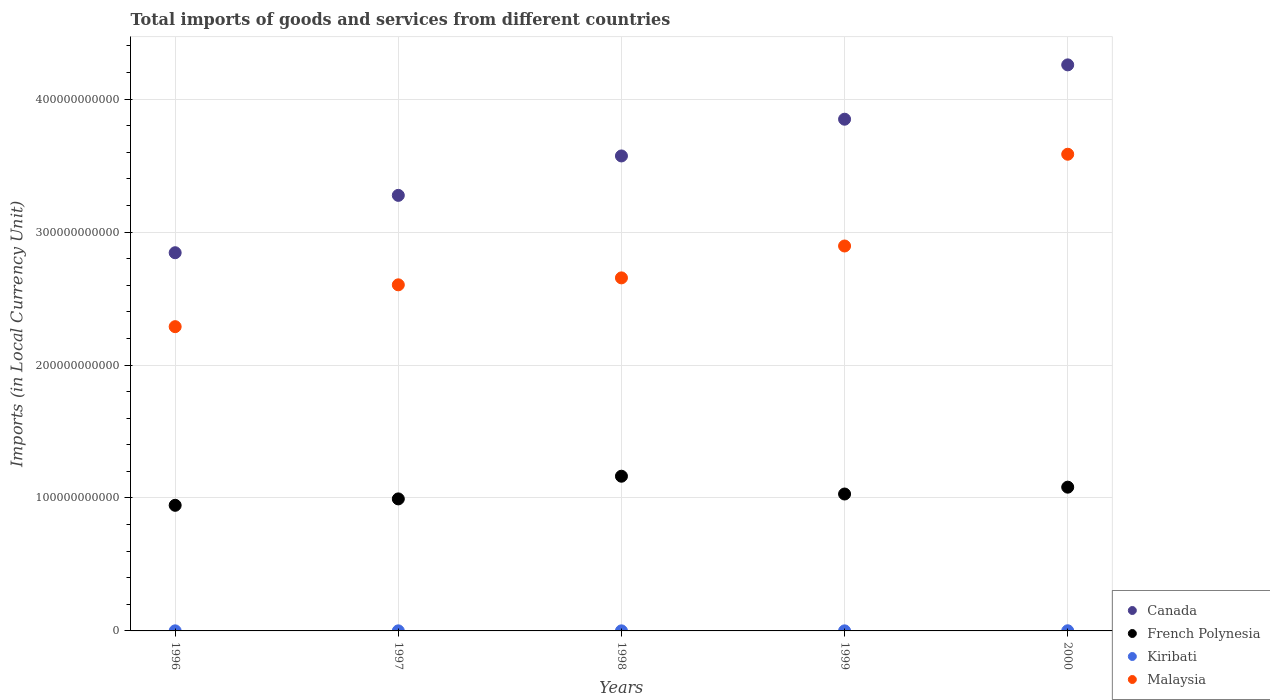Is the number of dotlines equal to the number of legend labels?
Keep it short and to the point. Yes. What is the Amount of goods and services imports in Malaysia in 1999?
Make the answer very short. 2.90e+11. Across all years, what is the maximum Amount of goods and services imports in Canada?
Offer a very short reply. 4.26e+11. Across all years, what is the minimum Amount of goods and services imports in Malaysia?
Ensure brevity in your answer.  2.29e+11. In which year was the Amount of goods and services imports in Canada maximum?
Your response must be concise. 2000. What is the total Amount of goods and services imports in French Polynesia in the graph?
Provide a short and direct response. 5.21e+11. What is the difference between the Amount of goods and services imports in French Polynesia in 1998 and that in 1999?
Offer a very short reply. 1.34e+1. What is the difference between the Amount of goods and services imports in Malaysia in 1997 and the Amount of goods and services imports in French Polynesia in 2000?
Give a very brief answer. 1.52e+11. What is the average Amount of goods and services imports in French Polynesia per year?
Ensure brevity in your answer.  1.04e+11. In the year 1996, what is the difference between the Amount of goods and services imports in French Polynesia and Amount of goods and services imports in Kiribati?
Offer a very short reply. 9.44e+1. In how many years, is the Amount of goods and services imports in Kiribati greater than 400000000000 LCU?
Offer a terse response. 0. What is the ratio of the Amount of goods and services imports in Malaysia in 1997 to that in 1998?
Your answer should be compact. 0.98. What is the difference between the highest and the second highest Amount of goods and services imports in Malaysia?
Offer a terse response. 6.90e+1. What is the difference between the highest and the lowest Amount of goods and services imports in Canada?
Give a very brief answer. 1.41e+11. Is the Amount of goods and services imports in Kiribati strictly greater than the Amount of goods and services imports in French Polynesia over the years?
Provide a short and direct response. No. Is the Amount of goods and services imports in Canada strictly less than the Amount of goods and services imports in French Polynesia over the years?
Your answer should be very brief. No. What is the difference between two consecutive major ticks on the Y-axis?
Provide a succinct answer. 1.00e+11. Are the values on the major ticks of Y-axis written in scientific E-notation?
Your answer should be compact. No. Does the graph contain any zero values?
Your answer should be very brief. No. What is the title of the graph?
Give a very brief answer. Total imports of goods and services from different countries. Does "American Samoa" appear as one of the legend labels in the graph?
Offer a very short reply. No. What is the label or title of the Y-axis?
Provide a short and direct response. Imports (in Local Currency Unit). What is the Imports (in Local Currency Unit) of Canada in 1996?
Offer a very short reply. 2.84e+11. What is the Imports (in Local Currency Unit) of French Polynesia in 1996?
Keep it short and to the point. 9.45e+1. What is the Imports (in Local Currency Unit) of Kiribati in 1996?
Provide a succinct answer. 5.91e+07. What is the Imports (in Local Currency Unit) in Malaysia in 1996?
Offer a terse response. 2.29e+11. What is the Imports (in Local Currency Unit) in Canada in 1997?
Keep it short and to the point. 3.28e+11. What is the Imports (in Local Currency Unit) of French Polynesia in 1997?
Provide a short and direct response. 9.93e+1. What is the Imports (in Local Currency Unit) in Kiribati in 1997?
Your answer should be compact. 5.78e+07. What is the Imports (in Local Currency Unit) of Malaysia in 1997?
Make the answer very short. 2.60e+11. What is the Imports (in Local Currency Unit) of Canada in 1998?
Give a very brief answer. 3.57e+11. What is the Imports (in Local Currency Unit) of French Polynesia in 1998?
Provide a succinct answer. 1.16e+11. What is the Imports (in Local Currency Unit) in Kiribati in 1998?
Provide a succinct answer. 5.53e+07. What is the Imports (in Local Currency Unit) in Malaysia in 1998?
Your response must be concise. 2.66e+11. What is the Imports (in Local Currency Unit) of Canada in 1999?
Your answer should be very brief. 3.85e+11. What is the Imports (in Local Currency Unit) in French Polynesia in 1999?
Keep it short and to the point. 1.03e+11. What is the Imports (in Local Currency Unit) in Kiribati in 1999?
Keep it short and to the point. 5.76e+07. What is the Imports (in Local Currency Unit) in Malaysia in 1999?
Your response must be concise. 2.90e+11. What is the Imports (in Local Currency Unit) of Canada in 2000?
Keep it short and to the point. 4.26e+11. What is the Imports (in Local Currency Unit) of French Polynesia in 2000?
Make the answer very short. 1.08e+11. What is the Imports (in Local Currency Unit) of Kiribati in 2000?
Offer a very short reply. 1.08e+08. What is the Imports (in Local Currency Unit) of Malaysia in 2000?
Keep it short and to the point. 3.59e+11. Across all years, what is the maximum Imports (in Local Currency Unit) of Canada?
Make the answer very short. 4.26e+11. Across all years, what is the maximum Imports (in Local Currency Unit) of French Polynesia?
Provide a short and direct response. 1.16e+11. Across all years, what is the maximum Imports (in Local Currency Unit) in Kiribati?
Your response must be concise. 1.08e+08. Across all years, what is the maximum Imports (in Local Currency Unit) in Malaysia?
Provide a short and direct response. 3.59e+11. Across all years, what is the minimum Imports (in Local Currency Unit) of Canada?
Keep it short and to the point. 2.84e+11. Across all years, what is the minimum Imports (in Local Currency Unit) of French Polynesia?
Offer a terse response. 9.45e+1. Across all years, what is the minimum Imports (in Local Currency Unit) of Kiribati?
Offer a terse response. 5.53e+07. Across all years, what is the minimum Imports (in Local Currency Unit) in Malaysia?
Offer a very short reply. 2.29e+11. What is the total Imports (in Local Currency Unit) in Canada in the graph?
Offer a terse response. 1.78e+12. What is the total Imports (in Local Currency Unit) of French Polynesia in the graph?
Offer a very short reply. 5.21e+11. What is the total Imports (in Local Currency Unit) in Kiribati in the graph?
Offer a terse response. 3.38e+08. What is the total Imports (in Local Currency Unit) of Malaysia in the graph?
Keep it short and to the point. 1.40e+12. What is the difference between the Imports (in Local Currency Unit) in Canada in 1996 and that in 1997?
Provide a short and direct response. -4.31e+1. What is the difference between the Imports (in Local Currency Unit) of French Polynesia in 1996 and that in 1997?
Offer a terse response. -4.82e+09. What is the difference between the Imports (in Local Currency Unit) in Kiribati in 1996 and that in 1997?
Make the answer very short. 1.30e+06. What is the difference between the Imports (in Local Currency Unit) of Malaysia in 1996 and that in 1997?
Your response must be concise. -3.15e+1. What is the difference between the Imports (in Local Currency Unit) in Canada in 1996 and that in 1998?
Keep it short and to the point. -7.28e+1. What is the difference between the Imports (in Local Currency Unit) of French Polynesia in 1996 and that in 1998?
Offer a very short reply. -2.19e+1. What is the difference between the Imports (in Local Currency Unit) of Kiribati in 1996 and that in 1998?
Your answer should be compact. 3.78e+06. What is the difference between the Imports (in Local Currency Unit) of Malaysia in 1996 and that in 1998?
Ensure brevity in your answer.  -3.67e+1. What is the difference between the Imports (in Local Currency Unit) of Canada in 1996 and that in 1999?
Your answer should be compact. -1.00e+11. What is the difference between the Imports (in Local Currency Unit) in French Polynesia in 1996 and that in 1999?
Ensure brevity in your answer.  -8.49e+09. What is the difference between the Imports (in Local Currency Unit) of Kiribati in 1996 and that in 1999?
Your answer should be compact. 1.50e+06. What is the difference between the Imports (in Local Currency Unit) in Malaysia in 1996 and that in 1999?
Offer a very short reply. -6.07e+1. What is the difference between the Imports (in Local Currency Unit) in Canada in 1996 and that in 2000?
Your answer should be very brief. -1.41e+11. What is the difference between the Imports (in Local Currency Unit) in French Polynesia in 1996 and that in 2000?
Offer a very short reply. -1.36e+1. What is the difference between the Imports (in Local Currency Unit) of Kiribati in 1996 and that in 2000?
Your answer should be very brief. -4.87e+07. What is the difference between the Imports (in Local Currency Unit) of Malaysia in 1996 and that in 2000?
Offer a terse response. -1.30e+11. What is the difference between the Imports (in Local Currency Unit) in Canada in 1997 and that in 1998?
Make the answer very short. -2.96e+1. What is the difference between the Imports (in Local Currency Unit) in French Polynesia in 1997 and that in 1998?
Your response must be concise. -1.71e+1. What is the difference between the Imports (in Local Currency Unit) in Kiribati in 1997 and that in 1998?
Your answer should be compact. 2.48e+06. What is the difference between the Imports (in Local Currency Unit) of Malaysia in 1997 and that in 1998?
Your answer should be very brief. -5.23e+09. What is the difference between the Imports (in Local Currency Unit) in Canada in 1997 and that in 1999?
Make the answer very short. -5.73e+1. What is the difference between the Imports (in Local Currency Unit) in French Polynesia in 1997 and that in 1999?
Provide a short and direct response. -3.67e+09. What is the difference between the Imports (in Local Currency Unit) in Malaysia in 1997 and that in 1999?
Your response must be concise. -2.92e+1. What is the difference between the Imports (in Local Currency Unit) of Canada in 1997 and that in 2000?
Ensure brevity in your answer.  -9.82e+1. What is the difference between the Imports (in Local Currency Unit) of French Polynesia in 1997 and that in 2000?
Your answer should be compact. -8.82e+09. What is the difference between the Imports (in Local Currency Unit) of Kiribati in 1997 and that in 2000?
Offer a terse response. -5.00e+07. What is the difference between the Imports (in Local Currency Unit) of Malaysia in 1997 and that in 2000?
Offer a very short reply. -9.82e+1. What is the difference between the Imports (in Local Currency Unit) of Canada in 1998 and that in 1999?
Offer a very short reply. -2.76e+1. What is the difference between the Imports (in Local Currency Unit) of French Polynesia in 1998 and that in 1999?
Your answer should be very brief. 1.34e+1. What is the difference between the Imports (in Local Currency Unit) in Kiribati in 1998 and that in 1999?
Provide a short and direct response. -2.28e+06. What is the difference between the Imports (in Local Currency Unit) of Malaysia in 1998 and that in 1999?
Provide a short and direct response. -2.40e+1. What is the difference between the Imports (in Local Currency Unit) in Canada in 1998 and that in 2000?
Your answer should be very brief. -6.85e+1. What is the difference between the Imports (in Local Currency Unit) in French Polynesia in 1998 and that in 2000?
Provide a succinct answer. 8.23e+09. What is the difference between the Imports (in Local Currency Unit) in Kiribati in 1998 and that in 2000?
Provide a succinct answer. -5.24e+07. What is the difference between the Imports (in Local Currency Unit) in Malaysia in 1998 and that in 2000?
Your answer should be compact. -9.30e+1. What is the difference between the Imports (in Local Currency Unit) in Canada in 1999 and that in 2000?
Your answer should be very brief. -4.09e+1. What is the difference between the Imports (in Local Currency Unit) in French Polynesia in 1999 and that in 2000?
Provide a succinct answer. -5.15e+09. What is the difference between the Imports (in Local Currency Unit) of Kiribati in 1999 and that in 2000?
Offer a terse response. -5.02e+07. What is the difference between the Imports (in Local Currency Unit) of Malaysia in 1999 and that in 2000?
Give a very brief answer. -6.90e+1. What is the difference between the Imports (in Local Currency Unit) in Canada in 1996 and the Imports (in Local Currency Unit) in French Polynesia in 1997?
Ensure brevity in your answer.  1.85e+11. What is the difference between the Imports (in Local Currency Unit) in Canada in 1996 and the Imports (in Local Currency Unit) in Kiribati in 1997?
Offer a very short reply. 2.84e+11. What is the difference between the Imports (in Local Currency Unit) of Canada in 1996 and the Imports (in Local Currency Unit) of Malaysia in 1997?
Offer a terse response. 2.41e+1. What is the difference between the Imports (in Local Currency Unit) in French Polynesia in 1996 and the Imports (in Local Currency Unit) in Kiribati in 1997?
Your response must be concise. 9.44e+1. What is the difference between the Imports (in Local Currency Unit) in French Polynesia in 1996 and the Imports (in Local Currency Unit) in Malaysia in 1997?
Keep it short and to the point. -1.66e+11. What is the difference between the Imports (in Local Currency Unit) in Kiribati in 1996 and the Imports (in Local Currency Unit) in Malaysia in 1997?
Give a very brief answer. -2.60e+11. What is the difference between the Imports (in Local Currency Unit) of Canada in 1996 and the Imports (in Local Currency Unit) of French Polynesia in 1998?
Make the answer very short. 1.68e+11. What is the difference between the Imports (in Local Currency Unit) in Canada in 1996 and the Imports (in Local Currency Unit) in Kiribati in 1998?
Ensure brevity in your answer.  2.84e+11. What is the difference between the Imports (in Local Currency Unit) in Canada in 1996 and the Imports (in Local Currency Unit) in Malaysia in 1998?
Your answer should be compact. 1.89e+1. What is the difference between the Imports (in Local Currency Unit) of French Polynesia in 1996 and the Imports (in Local Currency Unit) of Kiribati in 1998?
Your answer should be compact. 9.44e+1. What is the difference between the Imports (in Local Currency Unit) of French Polynesia in 1996 and the Imports (in Local Currency Unit) of Malaysia in 1998?
Your answer should be very brief. -1.71e+11. What is the difference between the Imports (in Local Currency Unit) in Kiribati in 1996 and the Imports (in Local Currency Unit) in Malaysia in 1998?
Give a very brief answer. -2.65e+11. What is the difference between the Imports (in Local Currency Unit) in Canada in 1996 and the Imports (in Local Currency Unit) in French Polynesia in 1999?
Your response must be concise. 1.81e+11. What is the difference between the Imports (in Local Currency Unit) of Canada in 1996 and the Imports (in Local Currency Unit) of Kiribati in 1999?
Provide a succinct answer. 2.84e+11. What is the difference between the Imports (in Local Currency Unit) in Canada in 1996 and the Imports (in Local Currency Unit) in Malaysia in 1999?
Provide a short and direct response. -5.06e+09. What is the difference between the Imports (in Local Currency Unit) of French Polynesia in 1996 and the Imports (in Local Currency Unit) of Kiribati in 1999?
Give a very brief answer. 9.44e+1. What is the difference between the Imports (in Local Currency Unit) of French Polynesia in 1996 and the Imports (in Local Currency Unit) of Malaysia in 1999?
Provide a short and direct response. -1.95e+11. What is the difference between the Imports (in Local Currency Unit) of Kiribati in 1996 and the Imports (in Local Currency Unit) of Malaysia in 1999?
Make the answer very short. -2.89e+11. What is the difference between the Imports (in Local Currency Unit) of Canada in 1996 and the Imports (in Local Currency Unit) of French Polynesia in 2000?
Your response must be concise. 1.76e+11. What is the difference between the Imports (in Local Currency Unit) of Canada in 1996 and the Imports (in Local Currency Unit) of Kiribati in 2000?
Provide a short and direct response. 2.84e+11. What is the difference between the Imports (in Local Currency Unit) of Canada in 1996 and the Imports (in Local Currency Unit) of Malaysia in 2000?
Provide a succinct answer. -7.41e+1. What is the difference between the Imports (in Local Currency Unit) in French Polynesia in 1996 and the Imports (in Local Currency Unit) in Kiribati in 2000?
Your answer should be very brief. 9.44e+1. What is the difference between the Imports (in Local Currency Unit) of French Polynesia in 1996 and the Imports (in Local Currency Unit) of Malaysia in 2000?
Your answer should be very brief. -2.64e+11. What is the difference between the Imports (in Local Currency Unit) in Kiribati in 1996 and the Imports (in Local Currency Unit) in Malaysia in 2000?
Make the answer very short. -3.58e+11. What is the difference between the Imports (in Local Currency Unit) of Canada in 1997 and the Imports (in Local Currency Unit) of French Polynesia in 1998?
Ensure brevity in your answer.  2.11e+11. What is the difference between the Imports (in Local Currency Unit) of Canada in 1997 and the Imports (in Local Currency Unit) of Kiribati in 1998?
Your answer should be compact. 3.28e+11. What is the difference between the Imports (in Local Currency Unit) in Canada in 1997 and the Imports (in Local Currency Unit) in Malaysia in 1998?
Your response must be concise. 6.21e+1. What is the difference between the Imports (in Local Currency Unit) in French Polynesia in 1997 and the Imports (in Local Currency Unit) in Kiribati in 1998?
Offer a very short reply. 9.92e+1. What is the difference between the Imports (in Local Currency Unit) of French Polynesia in 1997 and the Imports (in Local Currency Unit) of Malaysia in 1998?
Your answer should be very brief. -1.66e+11. What is the difference between the Imports (in Local Currency Unit) of Kiribati in 1997 and the Imports (in Local Currency Unit) of Malaysia in 1998?
Offer a very short reply. -2.65e+11. What is the difference between the Imports (in Local Currency Unit) of Canada in 1997 and the Imports (in Local Currency Unit) of French Polynesia in 1999?
Offer a terse response. 2.25e+11. What is the difference between the Imports (in Local Currency Unit) in Canada in 1997 and the Imports (in Local Currency Unit) in Kiribati in 1999?
Make the answer very short. 3.28e+11. What is the difference between the Imports (in Local Currency Unit) of Canada in 1997 and the Imports (in Local Currency Unit) of Malaysia in 1999?
Your response must be concise. 3.81e+1. What is the difference between the Imports (in Local Currency Unit) of French Polynesia in 1997 and the Imports (in Local Currency Unit) of Kiribati in 1999?
Your response must be concise. 9.92e+1. What is the difference between the Imports (in Local Currency Unit) of French Polynesia in 1997 and the Imports (in Local Currency Unit) of Malaysia in 1999?
Offer a very short reply. -1.90e+11. What is the difference between the Imports (in Local Currency Unit) in Kiribati in 1997 and the Imports (in Local Currency Unit) in Malaysia in 1999?
Offer a very short reply. -2.89e+11. What is the difference between the Imports (in Local Currency Unit) in Canada in 1997 and the Imports (in Local Currency Unit) in French Polynesia in 2000?
Ensure brevity in your answer.  2.19e+11. What is the difference between the Imports (in Local Currency Unit) of Canada in 1997 and the Imports (in Local Currency Unit) of Kiribati in 2000?
Your answer should be very brief. 3.27e+11. What is the difference between the Imports (in Local Currency Unit) of Canada in 1997 and the Imports (in Local Currency Unit) of Malaysia in 2000?
Keep it short and to the point. -3.09e+1. What is the difference between the Imports (in Local Currency Unit) in French Polynesia in 1997 and the Imports (in Local Currency Unit) in Kiribati in 2000?
Offer a very short reply. 9.92e+1. What is the difference between the Imports (in Local Currency Unit) in French Polynesia in 1997 and the Imports (in Local Currency Unit) in Malaysia in 2000?
Your response must be concise. -2.59e+11. What is the difference between the Imports (in Local Currency Unit) of Kiribati in 1997 and the Imports (in Local Currency Unit) of Malaysia in 2000?
Keep it short and to the point. -3.58e+11. What is the difference between the Imports (in Local Currency Unit) of Canada in 1998 and the Imports (in Local Currency Unit) of French Polynesia in 1999?
Your response must be concise. 2.54e+11. What is the difference between the Imports (in Local Currency Unit) of Canada in 1998 and the Imports (in Local Currency Unit) of Kiribati in 1999?
Provide a short and direct response. 3.57e+11. What is the difference between the Imports (in Local Currency Unit) of Canada in 1998 and the Imports (in Local Currency Unit) of Malaysia in 1999?
Provide a succinct answer. 6.77e+1. What is the difference between the Imports (in Local Currency Unit) in French Polynesia in 1998 and the Imports (in Local Currency Unit) in Kiribati in 1999?
Keep it short and to the point. 1.16e+11. What is the difference between the Imports (in Local Currency Unit) of French Polynesia in 1998 and the Imports (in Local Currency Unit) of Malaysia in 1999?
Provide a short and direct response. -1.73e+11. What is the difference between the Imports (in Local Currency Unit) of Kiribati in 1998 and the Imports (in Local Currency Unit) of Malaysia in 1999?
Offer a very short reply. -2.89e+11. What is the difference between the Imports (in Local Currency Unit) of Canada in 1998 and the Imports (in Local Currency Unit) of French Polynesia in 2000?
Offer a terse response. 2.49e+11. What is the difference between the Imports (in Local Currency Unit) of Canada in 1998 and the Imports (in Local Currency Unit) of Kiribati in 2000?
Ensure brevity in your answer.  3.57e+11. What is the difference between the Imports (in Local Currency Unit) of Canada in 1998 and the Imports (in Local Currency Unit) of Malaysia in 2000?
Offer a terse response. -1.29e+09. What is the difference between the Imports (in Local Currency Unit) of French Polynesia in 1998 and the Imports (in Local Currency Unit) of Kiribati in 2000?
Offer a terse response. 1.16e+11. What is the difference between the Imports (in Local Currency Unit) in French Polynesia in 1998 and the Imports (in Local Currency Unit) in Malaysia in 2000?
Provide a short and direct response. -2.42e+11. What is the difference between the Imports (in Local Currency Unit) of Kiribati in 1998 and the Imports (in Local Currency Unit) of Malaysia in 2000?
Make the answer very short. -3.58e+11. What is the difference between the Imports (in Local Currency Unit) in Canada in 1999 and the Imports (in Local Currency Unit) in French Polynesia in 2000?
Offer a very short reply. 2.77e+11. What is the difference between the Imports (in Local Currency Unit) in Canada in 1999 and the Imports (in Local Currency Unit) in Kiribati in 2000?
Your answer should be compact. 3.85e+11. What is the difference between the Imports (in Local Currency Unit) in Canada in 1999 and the Imports (in Local Currency Unit) in Malaysia in 2000?
Make the answer very short. 2.63e+1. What is the difference between the Imports (in Local Currency Unit) of French Polynesia in 1999 and the Imports (in Local Currency Unit) of Kiribati in 2000?
Keep it short and to the point. 1.03e+11. What is the difference between the Imports (in Local Currency Unit) in French Polynesia in 1999 and the Imports (in Local Currency Unit) in Malaysia in 2000?
Keep it short and to the point. -2.56e+11. What is the difference between the Imports (in Local Currency Unit) of Kiribati in 1999 and the Imports (in Local Currency Unit) of Malaysia in 2000?
Your response must be concise. -3.58e+11. What is the average Imports (in Local Currency Unit) in Canada per year?
Your answer should be compact. 3.56e+11. What is the average Imports (in Local Currency Unit) in French Polynesia per year?
Your answer should be compact. 1.04e+11. What is the average Imports (in Local Currency Unit) of Kiribati per year?
Provide a succinct answer. 6.75e+07. What is the average Imports (in Local Currency Unit) of Malaysia per year?
Keep it short and to the point. 2.81e+11. In the year 1996, what is the difference between the Imports (in Local Currency Unit) in Canada and Imports (in Local Currency Unit) in French Polynesia?
Offer a terse response. 1.90e+11. In the year 1996, what is the difference between the Imports (in Local Currency Unit) in Canada and Imports (in Local Currency Unit) in Kiribati?
Offer a terse response. 2.84e+11. In the year 1996, what is the difference between the Imports (in Local Currency Unit) of Canada and Imports (in Local Currency Unit) of Malaysia?
Provide a succinct answer. 5.56e+1. In the year 1996, what is the difference between the Imports (in Local Currency Unit) in French Polynesia and Imports (in Local Currency Unit) in Kiribati?
Give a very brief answer. 9.44e+1. In the year 1996, what is the difference between the Imports (in Local Currency Unit) in French Polynesia and Imports (in Local Currency Unit) in Malaysia?
Your answer should be compact. -1.34e+11. In the year 1996, what is the difference between the Imports (in Local Currency Unit) in Kiribati and Imports (in Local Currency Unit) in Malaysia?
Provide a succinct answer. -2.29e+11. In the year 1997, what is the difference between the Imports (in Local Currency Unit) in Canada and Imports (in Local Currency Unit) in French Polynesia?
Make the answer very short. 2.28e+11. In the year 1997, what is the difference between the Imports (in Local Currency Unit) of Canada and Imports (in Local Currency Unit) of Kiribati?
Make the answer very short. 3.28e+11. In the year 1997, what is the difference between the Imports (in Local Currency Unit) of Canada and Imports (in Local Currency Unit) of Malaysia?
Your response must be concise. 6.73e+1. In the year 1997, what is the difference between the Imports (in Local Currency Unit) of French Polynesia and Imports (in Local Currency Unit) of Kiribati?
Provide a short and direct response. 9.92e+1. In the year 1997, what is the difference between the Imports (in Local Currency Unit) in French Polynesia and Imports (in Local Currency Unit) in Malaysia?
Your response must be concise. -1.61e+11. In the year 1997, what is the difference between the Imports (in Local Currency Unit) of Kiribati and Imports (in Local Currency Unit) of Malaysia?
Give a very brief answer. -2.60e+11. In the year 1998, what is the difference between the Imports (in Local Currency Unit) of Canada and Imports (in Local Currency Unit) of French Polynesia?
Your response must be concise. 2.41e+11. In the year 1998, what is the difference between the Imports (in Local Currency Unit) of Canada and Imports (in Local Currency Unit) of Kiribati?
Offer a very short reply. 3.57e+11. In the year 1998, what is the difference between the Imports (in Local Currency Unit) of Canada and Imports (in Local Currency Unit) of Malaysia?
Your answer should be very brief. 9.17e+1. In the year 1998, what is the difference between the Imports (in Local Currency Unit) in French Polynesia and Imports (in Local Currency Unit) in Kiribati?
Your response must be concise. 1.16e+11. In the year 1998, what is the difference between the Imports (in Local Currency Unit) in French Polynesia and Imports (in Local Currency Unit) in Malaysia?
Your response must be concise. -1.49e+11. In the year 1998, what is the difference between the Imports (in Local Currency Unit) in Kiribati and Imports (in Local Currency Unit) in Malaysia?
Make the answer very short. -2.65e+11. In the year 1999, what is the difference between the Imports (in Local Currency Unit) of Canada and Imports (in Local Currency Unit) of French Polynesia?
Offer a very short reply. 2.82e+11. In the year 1999, what is the difference between the Imports (in Local Currency Unit) in Canada and Imports (in Local Currency Unit) in Kiribati?
Your response must be concise. 3.85e+11. In the year 1999, what is the difference between the Imports (in Local Currency Unit) of Canada and Imports (in Local Currency Unit) of Malaysia?
Keep it short and to the point. 9.54e+1. In the year 1999, what is the difference between the Imports (in Local Currency Unit) in French Polynesia and Imports (in Local Currency Unit) in Kiribati?
Your answer should be very brief. 1.03e+11. In the year 1999, what is the difference between the Imports (in Local Currency Unit) of French Polynesia and Imports (in Local Currency Unit) of Malaysia?
Provide a short and direct response. -1.87e+11. In the year 1999, what is the difference between the Imports (in Local Currency Unit) of Kiribati and Imports (in Local Currency Unit) of Malaysia?
Your response must be concise. -2.89e+11. In the year 2000, what is the difference between the Imports (in Local Currency Unit) of Canada and Imports (in Local Currency Unit) of French Polynesia?
Ensure brevity in your answer.  3.18e+11. In the year 2000, what is the difference between the Imports (in Local Currency Unit) of Canada and Imports (in Local Currency Unit) of Kiribati?
Offer a very short reply. 4.26e+11. In the year 2000, what is the difference between the Imports (in Local Currency Unit) in Canada and Imports (in Local Currency Unit) in Malaysia?
Offer a terse response. 6.72e+1. In the year 2000, what is the difference between the Imports (in Local Currency Unit) of French Polynesia and Imports (in Local Currency Unit) of Kiribati?
Provide a short and direct response. 1.08e+11. In the year 2000, what is the difference between the Imports (in Local Currency Unit) in French Polynesia and Imports (in Local Currency Unit) in Malaysia?
Keep it short and to the point. -2.50e+11. In the year 2000, what is the difference between the Imports (in Local Currency Unit) in Kiribati and Imports (in Local Currency Unit) in Malaysia?
Provide a succinct answer. -3.58e+11. What is the ratio of the Imports (in Local Currency Unit) in Canada in 1996 to that in 1997?
Your answer should be very brief. 0.87. What is the ratio of the Imports (in Local Currency Unit) in French Polynesia in 1996 to that in 1997?
Your response must be concise. 0.95. What is the ratio of the Imports (in Local Currency Unit) in Kiribati in 1996 to that in 1997?
Your answer should be very brief. 1.02. What is the ratio of the Imports (in Local Currency Unit) in Malaysia in 1996 to that in 1997?
Your answer should be very brief. 0.88. What is the ratio of the Imports (in Local Currency Unit) in Canada in 1996 to that in 1998?
Keep it short and to the point. 0.8. What is the ratio of the Imports (in Local Currency Unit) in French Polynesia in 1996 to that in 1998?
Make the answer very short. 0.81. What is the ratio of the Imports (in Local Currency Unit) of Kiribati in 1996 to that in 1998?
Make the answer very short. 1.07. What is the ratio of the Imports (in Local Currency Unit) in Malaysia in 1996 to that in 1998?
Give a very brief answer. 0.86. What is the ratio of the Imports (in Local Currency Unit) of Canada in 1996 to that in 1999?
Offer a terse response. 0.74. What is the ratio of the Imports (in Local Currency Unit) in French Polynesia in 1996 to that in 1999?
Keep it short and to the point. 0.92. What is the ratio of the Imports (in Local Currency Unit) of Kiribati in 1996 to that in 1999?
Provide a succinct answer. 1.03. What is the ratio of the Imports (in Local Currency Unit) of Malaysia in 1996 to that in 1999?
Offer a very short reply. 0.79. What is the ratio of the Imports (in Local Currency Unit) in Canada in 1996 to that in 2000?
Your answer should be compact. 0.67. What is the ratio of the Imports (in Local Currency Unit) in French Polynesia in 1996 to that in 2000?
Keep it short and to the point. 0.87. What is the ratio of the Imports (in Local Currency Unit) of Kiribati in 1996 to that in 2000?
Provide a short and direct response. 0.55. What is the ratio of the Imports (in Local Currency Unit) in Malaysia in 1996 to that in 2000?
Offer a very short reply. 0.64. What is the ratio of the Imports (in Local Currency Unit) in Canada in 1997 to that in 1998?
Keep it short and to the point. 0.92. What is the ratio of the Imports (in Local Currency Unit) in French Polynesia in 1997 to that in 1998?
Your response must be concise. 0.85. What is the ratio of the Imports (in Local Currency Unit) of Kiribati in 1997 to that in 1998?
Ensure brevity in your answer.  1.04. What is the ratio of the Imports (in Local Currency Unit) in Malaysia in 1997 to that in 1998?
Give a very brief answer. 0.98. What is the ratio of the Imports (in Local Currency Unit) of Canada in 1997 to that in 1999?
Your answer should be very brief. 0.85. What is the ratio of the Imports (in Local Currency Unit) in Kiribati in 1997 to that in 1999?
Keep it short and to the point. 1. What is the ratio of the Imports (in Local Currency Unit) of Malaysia in 1997 to that in 1999?
Your answer should be very brief. 0.9. What is the ratio of the Imports (in Local Currency Unit) of Canada in 1997 to that in 2000?
Ensure brevity in your answer.  0.77. What is the ratio of the Imports (in Local Currency Unit) of French Polynesia in 1997 to that in 2000?
Provide a succinct answer. 0.92. What is the ratio of the Imports (in Local Currency Unit) of Kiribati in 1997 to that in 2000?
Give a very brief answer. 0.54. What is the ratio of the Imports (in Local Currency Unit) in Malaysia in 1997 to that in 2000?
Make the answer very short. 0.73. What is the ratio of the Imports (in Local Currency Unit) of Canada in 1998 to that in 1999?
Offer a terse response. 0.93. What is the ratio of the Imports (in Local Currency Unit) in French Polynesia in 1998 to that in 1999?
Give a very brief answer. 1.13. What is the ratio of the Imports (in Local Currency Unit) in Kiribati in 1998 to that in 1999?
Provide a succinct answer. 0.96. What is the ratio of the Imports (in Local Currency Unit) in Malaysia in 1998 to that in 1999?
Ensure brevity in your answer.  0.92. What is the ratio of the Imports (in Local Currency Unit) in Canada in 1998 to that in 2000?
Provide a short and direct response. 0.84. What is the ratio of the Imports (in Local Currency Unit) in French Polynesia in 1998 to that in 2000?
Your answer should be very brief. 1.08. What is the ratio of the Imports (in Local Currency Unit) in Kiribati in 1998 to that in 2000?
Give a very brief answer. 0.51. What is the ratio of the Imports (in Local Currency Unit) of Malaysia in 1998 to that in 2000?
Make the answer very short. 0.74. What is the ratio of the Imports (in Local Currency Unit) in Canada in 1999 to that in 2000?
Your answer should be very brief. 0.9. What is the ratio of the Imports (in Local Currency Unit) in Kiribati in 1999 to that in 2000?
Ensure brevity in your answer.  0.53. What is the ratio of the Imports (in Local Currency Unit) of Malaysia in 1999 to that in 2000?
Give a very brief answer. 0.81. What is the difference between the highest and the second highest Imports (in Local Currency Unit) of Canada?
Provide a succinct answer. 4.09e+1. What is the difference between the highest and the second highest Imports (in Local Currency Unit) of French Polynesia?
Make the answer very short. 8.23e+09. What is the difference between the highest and the second highest Imports (in Local Currency Unit) in Kiribati?
Offer a terse response. 4.87e+07. What is the difference between the highest and the second highest Imports (in Local Currency Unit) in Malaysia?
Keep it short and to the point. 6.90e+1. What is the difference between the highest and the lowest Imports (in Local Currency Unit) in Canada?
Your answer should be compact. 1.41e+11. What is the difference between the highest and the lowest Imports (in Local Currency Unit) in French Polynesia?
Offer a very short reply. 2.19e+1. What is the difference between the highest and the lowest Imports (in Local Currency Unit) of Kiribati?
Offer a terse response. 5.24e+07. What is the difference between the highest and the lowest Imports (in Local Currency Unit) in Malaysia?
Offer a very short reply. 1.30e+11. 